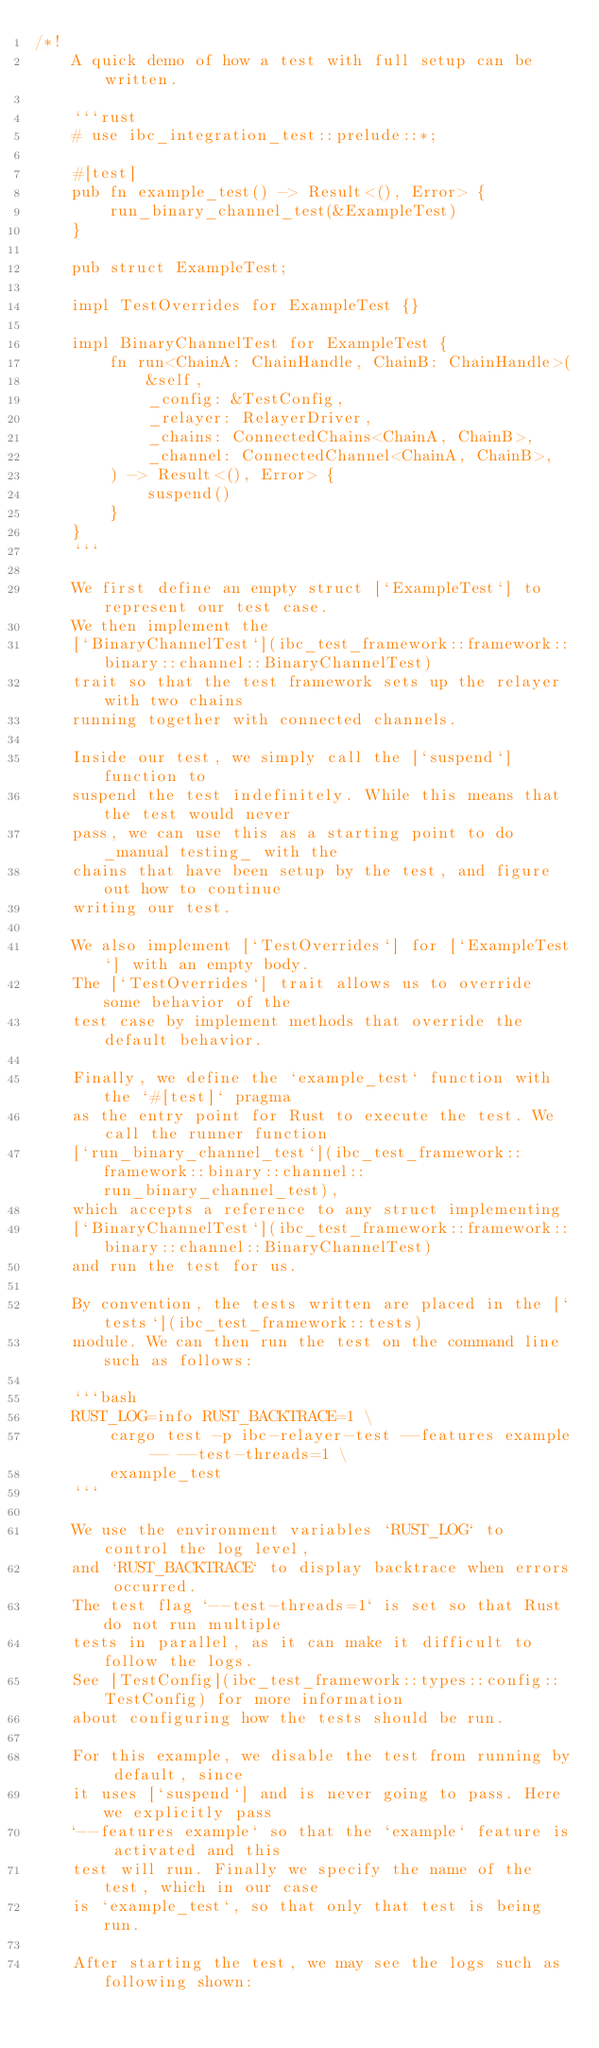<code> <loc_0><loc_0><loc_500><loc_500><_Rust_>/*!
    A quick demo of how a test with full setup can be written.

    ```rust
    # use ibc_integration_test::prelude::*;

    #[test]
    pub fn example_test() -> Result<(), Error> {
        run_binary_channel_test(&ExampleTest)
    }

    pub struct ExampleTest;

    impl TestOverrides for ExampleTest {}

    impl BinaryChannelTest for ExampleTest {
        fn run<ChainA: ChainHandle, ChainB: ChainHandle>(
            &self,
            _config: &TestConfig,
            _relayer: RelayerDriver,
            _chains: ConnectedChains<ChainA, ChainB>,
            _channel: ConnectedChannel<ChainA, ChainB>,
        ) -> Result<(), Error> {
            suspend()
        }
    }
    ```

    We first define an empty struct [`ExampleTest`] to represent our test case.
    We then implement the
    [`BinaryChannelTest`](ibc_test_framework::framework::binary::channel::BinaryChannelTest)
    trait so that the test framework sets up the relayer with two chains
    running together with connected channels.

    Inside our test, we simply call the [`suspend`] function to
    suspend the test indefinitely. While this means that the test would never
    pass, we can use this as a starting point to do _manual testing_ with the
    chains that have been setup by the test, and figure out how to continue
    writing our test.

    We also implement [`TestOverrides`] for [`ExampleTest`] with an empty body.
    The [`TestOverrides`] trait allows us to override some behavior of the
    test case by implement methods that override the default behavior.

    Finally, we define the `example_test` function with the `#[test]` pragma
    as the entry point for Rust to execute the test. We call the runner function
    [`run_binary_channel_test`](ibc_test_framework::framework::binary::channel::run_binary_channel_test),
    which accepts a reference to any struct implementing
    [`BinaryChannelTest`](ibc_test_framework::framework::binary::channel::BinaryChannelTest)
    and run the test for us.

    By convention, the tests written are placed in the [`tests`](ibc_test_framework::tests)
    module. We can then run the test on the command line such as follows:

    ```bash
    RUST_LOG=info RUST_BACKTRACE=1 \
        cargo test -p ibc-relayer-test --features example -- --test-threads=1 \
        example_test
    ```

    We use the environment variables `RUST_LOG` to control the log level,
    and `RUST_BACKTRACE` to display backtrace when errors occurred.
    The test flag `--test-threads=1` is set so that Rust do not run multiple
    tests in parallel, as it can make it difficult to follow the logs.
    See [TestConfig](ibc_test_framework::types::config::TestConfig) for more information
    about configuring how the tests should be run.

    For this example, we disable the test from running by default, since
    it uses [`suspend`] and is never going to pass. Here we explicitly pass
    `--features example` so that the `example` feature is activated and this
    test will run. Finally we specify the name of the test, which in our case
    is `example_test`, so that only that test is being run.

    After starting the test, we may see the logs such as following shown:
</code> 